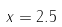<formula> <loc_0><loc_0><loc_500><loc_500>x = 2 . 5</formula> 